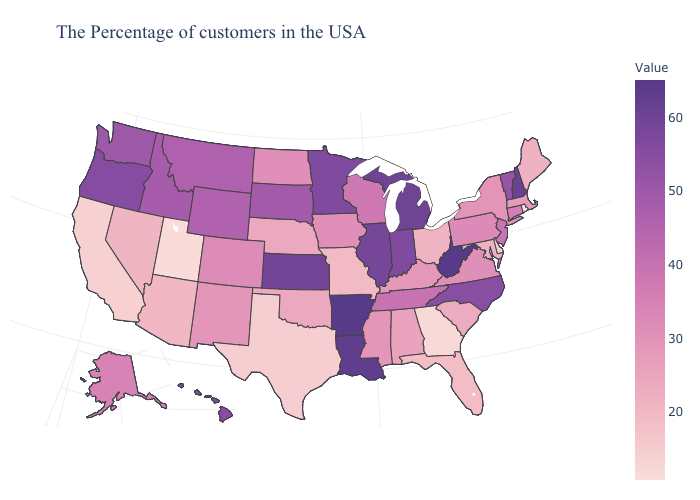Does California have the highest value in the USA?
Short answer required. No. Which states have the lowest value in the USA?
Answer briefly. Rhode Island. Does Rhode Island have the lowest value in the USA?
Quick response, please. Yes. Among the states that border California , does Arizona have the highest value?
Give a very brief answer. No. 